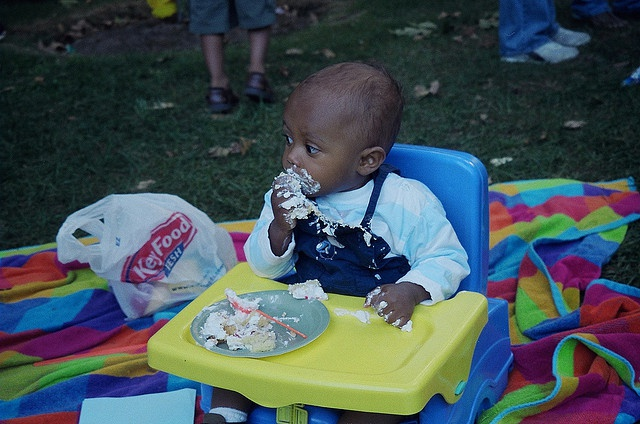Describe the objects in this image and their specific colors. I can see people in black, gray, lightblue, and navy tones, chair in black, blue, gray, and darkblue tones, people in black, navy, and gray tones, people in black, navy, blue, and gray tones, and cake in black, darkgray, lightblue, and lightgray tones in this image. 